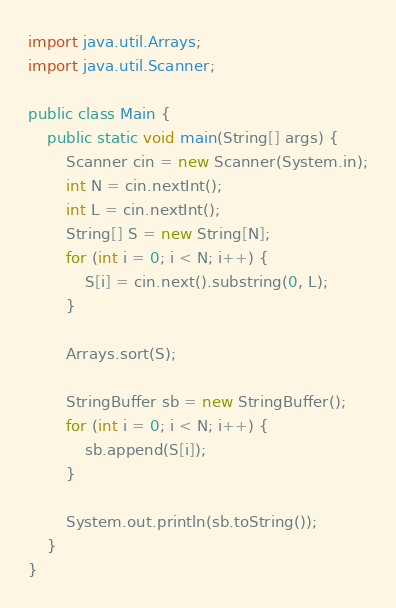<code> <loc_0><loc_0><loc_500><loc_500><_Java_>import java.util.Arrays;
import java.util.Scanner;

public class Main {
    public static void main(String[] args) {
        Scanner cin = new Scanner(System.in);
        int N = cin.nextInt();
        int L = cin.nextInt();
        String[] S = new String[N];
        for (int i = 0; i < N; i++) {
            S[i] = cin.next().substring(0, L);
        }

        Arrays.sort(S);

        StringBuffer sb = new StringBuffer();
        for (int i = 0; i < N; i++) {
            sb.append(S[i]);
        }

        System.out.println(sb.toString());
    }
}
</code> 